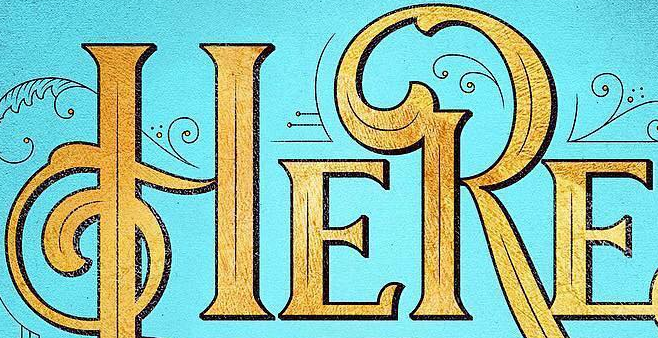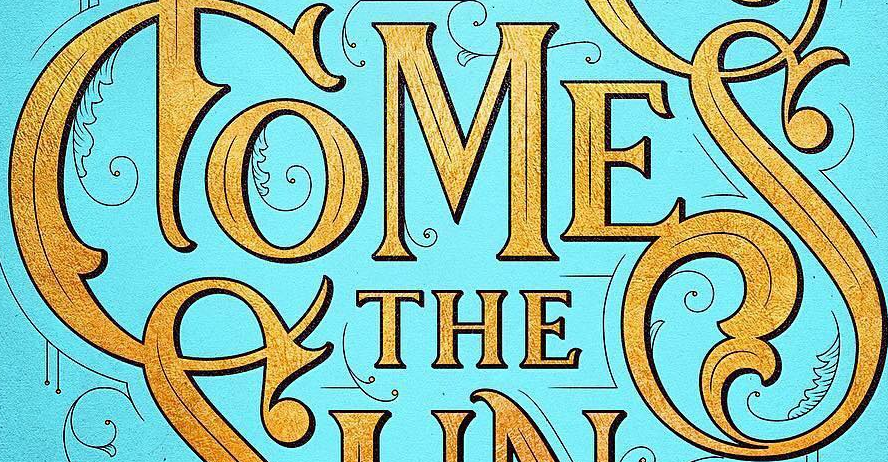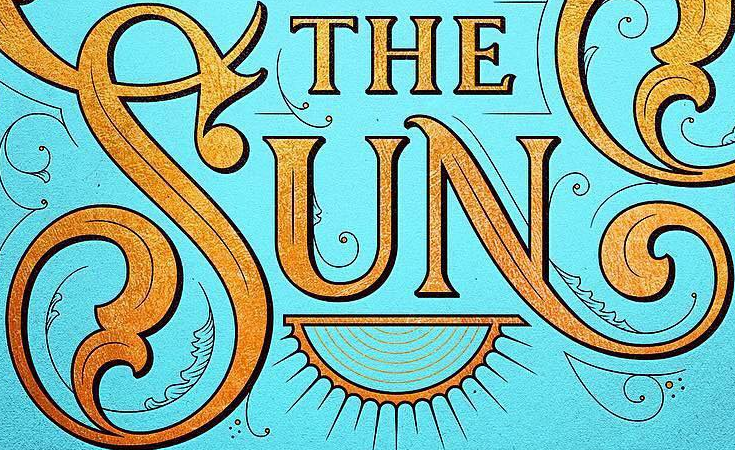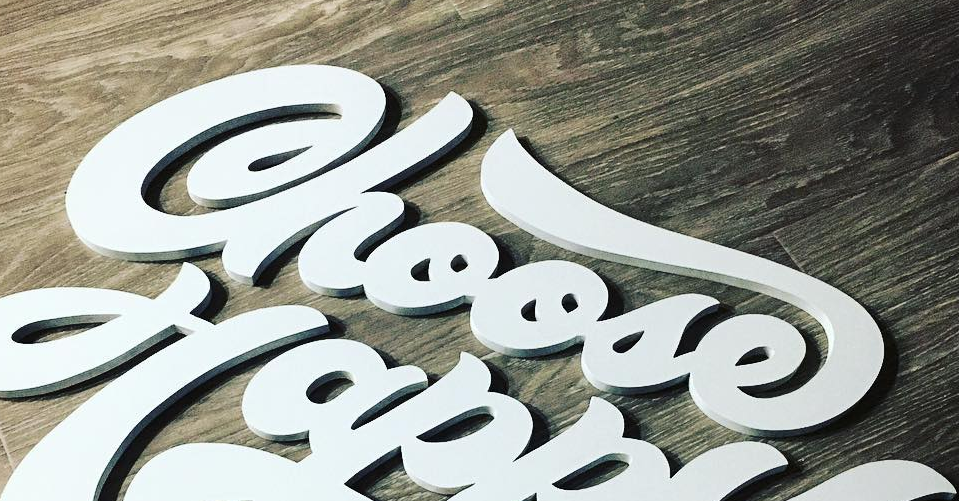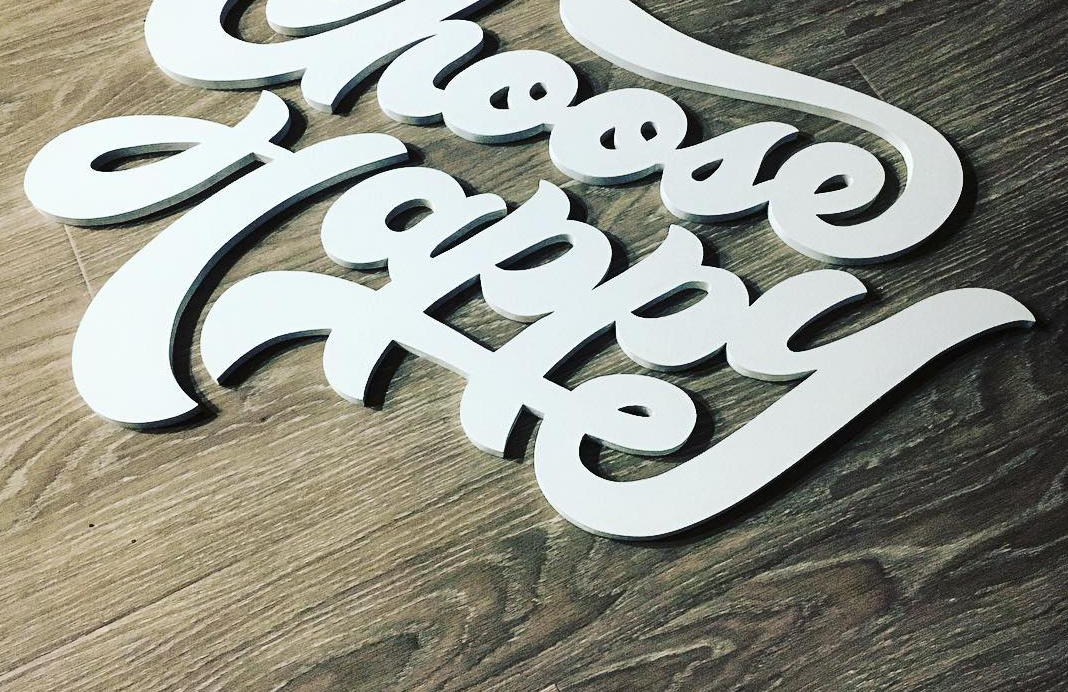Read the text from these images in sequence, separated by a semicolon. HERE; COMES; SUN; Choose; Happy 